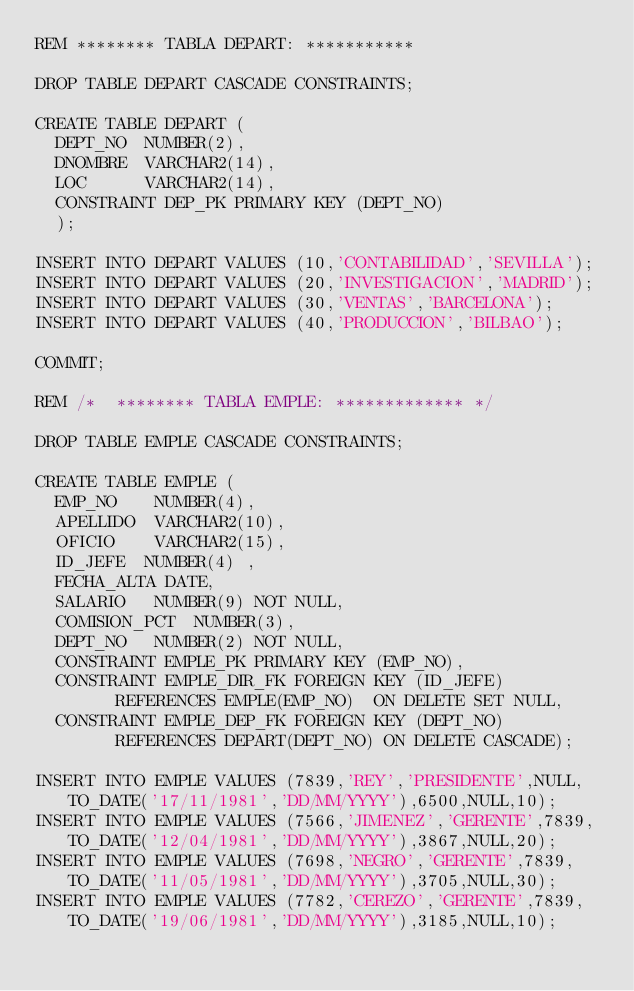<code> <loc_0><loc_0><loc_500><loc_500><_SQL_>REM ******** TABLA DEPART: *********** 

DROP TABLE DEPART CASCADE CONSTRAINTS; 

CREATE TABLE DEPART (
 	DEPT_NO  NUMBER(2),
	DNOMBRE  VARCHAR2(14), 
 	LOC      VARCHAR2(14),
	CONSTRAINT DEP_PK PRIMARY KEY (DEPT_NO)
	);

INSERT INTO DEPART VALUES (10,'CONTABILIDAD','SEVILLA');
INSERT INTO DEPART VALUES (20,'INVESTIGACION','MADRID');
INSERT INTO DEPART VALUES (30,'VENTAS','BARCELONA');
INSERT INTO DEPART VALUES (40,'PRODUCCION','BILBAO');

COMMIT;

REM /*  ******** TABLA EMPLE: ************* */

DROP TABLE EMPLE CASCADE CONSTRAINTS; 

CREATE TABLE EMPLE (
 	EMP_NO    NUMBER(4),
 	APELLIDO  VARCHAR2(10),
 	OFICIO    VARCHAR2(15),
 	ID_JEFE  NUMBER(4) ,
 	FECHA_ALTA DATE,
 	SALARIO   NUMBER(9) NOT NULL,
 	COMISION_PCT  NUMBER(3),
 	DEPT_NO   NUMBER(2) NOT NULL,
	CONSTRAINT EMPLE_PK PRIMARY KEY (EMP_NO),
	CONSTRAINT EMPLE_DIR_FK FOREIGN KEY (ID_JEFE)
				REFERENCES EMPLE(EMP_NO)  ON DELETE SET NULL,
	CONSTRAINT EMPLE_DEP_FK FOREIGN KEY (DEPT_NO)
				REFERENCES DEPART(DEPT_NO) ON DELETE CASCADE);

INSERT INTO EMPLE VALUES (7839,'REY','PRESIDENTE',NULL,TO_DATE('17/11/1981','DD/MM/YYYY'),6500,NULL,10);
INSERT INTO EMPLE VALUES (7566,'JIMENEZ','GERENTE',7839,TO_DATE('12/04/1981','DD/MM/YYYY'),3867,NULL,20);
INSERT INTO EMPLE VALUES (7698,'NEGRO','GERENTE',7839,TO_DATE('11/05/1981','DD/MM/YYYY'),3705,NULL,30);
INSERT INTO EMPLE VALUES (7782,'CEREZO','GERENTE',7839,TO_DATE('19/06/1981','DD/MM/YYYY'),3185,NULL,10);</code> 